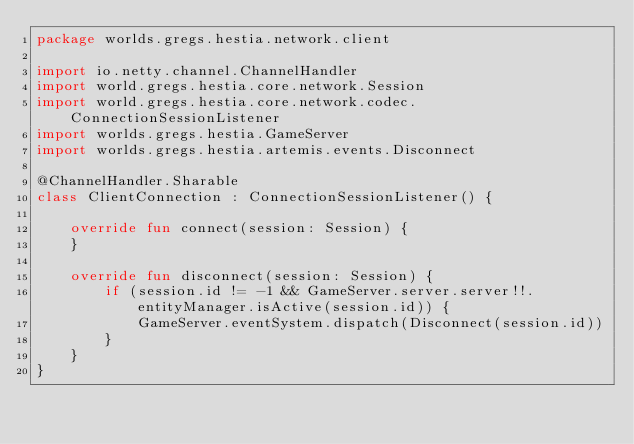<code> <loc_0><loc_0><loc_500><loc_500><_Kotlin_>package worlds.gregs.hestia.network.client

import io.netty.channel.ChannelHandler
import world.gregs.hestia.core.network.Session
import world.gregs.hestia.core.network.codec.ConnectionSessionListener
import worlds.gregs.hestia.GameServer
import worlds.gregs.hestia.artemis.events.Disconnect

@ChannelHandler.Sharable
class ClientConnection : ConnectionSessionListener() {

    override fun connect(session: Session) {
    }

    override fun disconnect(session: Session) {
        if (session.id != -1 && GameServer.server.server!!.entityManager.isActive(session.id)) {
            GameServer.eventSystem.dispatch(Disconnect(session.id))
        }
    }
}</code> 